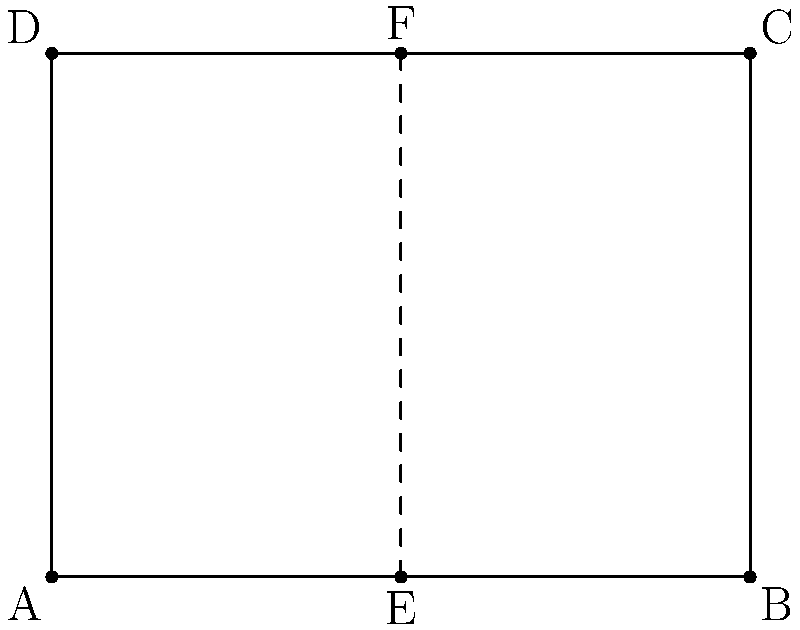In a classic Spanish horror film set, a rectangular room is designed with the following dimensions: width of 4 meters and height of 3 meters. A vertical line of symmetry is placed in the center of the room. If point A is at (0,0) and point B is at (4,0), what are the coordinates of point F? To solve this problem, let's follow these steps:

1. Understand the given information:
   - The room is rectangular with width 4m and height 3m.
   - Point A is at (0,0) and point B is at (4,0).
   - There's a vertical line of symmetry in the center of the room.

2. Identify the line of symmetry:
   - The line of symmetry is vertical and in the center of the room.
   - Since the width is 4m, the line of symmetry is at x = 2m.

3. Determine the x-coordinate of point F:
   - Point F is on the line of symmetry, so its x-coordinate is 2.

4. Determine the y-coordinate of point F:
   - Point F is at the top of the room.
   - The height of the room is 3m.
   - Therefore, the y-coordinate of F is 3.

5. Combine the x and y coordinates:
   - The coordinates of point F are (2,3).

This reflection symmetry is often used in horror film set designs to create a sense of balance and unease, as it can make the space feel both familiar and slightly off-putting.
Answer: (2,3) 